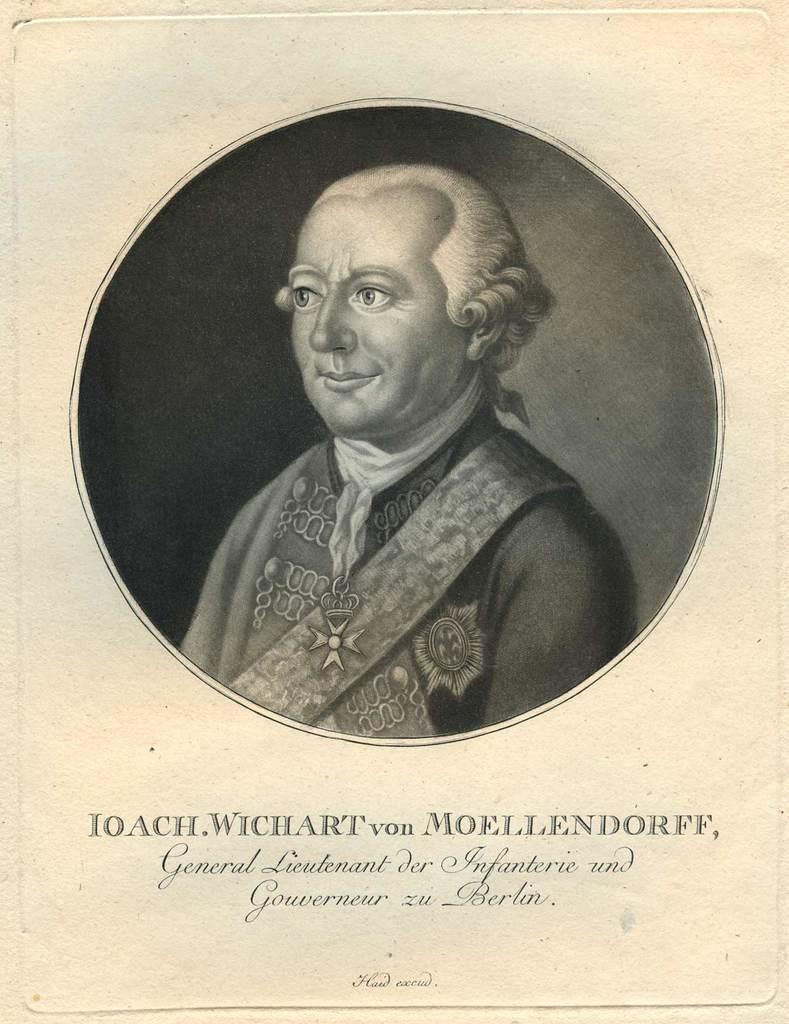Who or what is depicted in the image? There is an image of a person in the image. What else can be seen in the image besides the person? There is text on a paper in the image. How many windows are visible in the image? There are no windows visible in the image; it only contains an image of a person and text on a paper. 